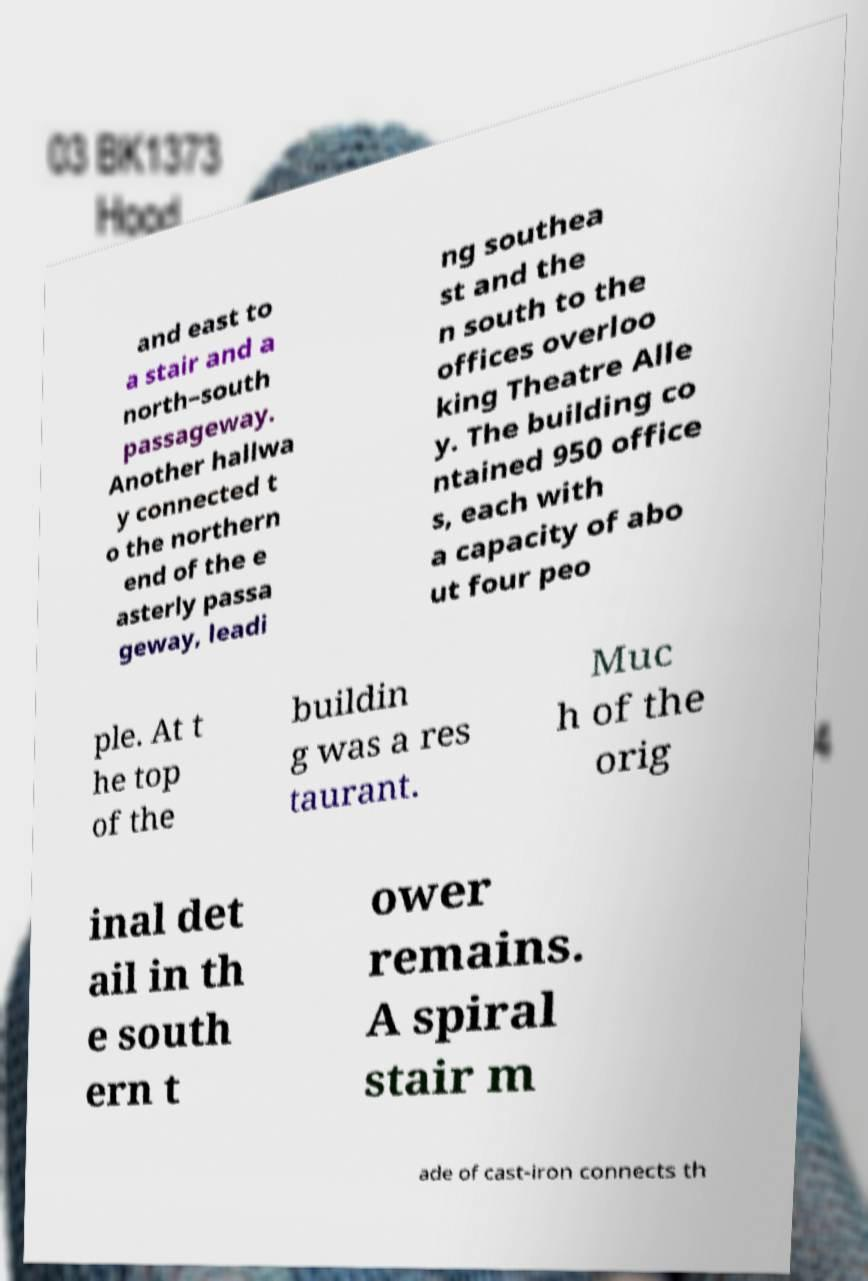Could you extract and type out the text from this image? and east to a stair and a north–south passageway. Another hallwa y connected t o the northern end of the e asterly passa geway, leadi ng southea st and the n south to the offices overloo king Theatre Alle y. The building co ntained 950 office s, each with a capacity of abo ut four peo ple. At t he top of the buildin g was a res taurant. Muc h of the orig inal det ail in th e south ern t ower remains. A spiral stair m ade of cast-iron connects th 